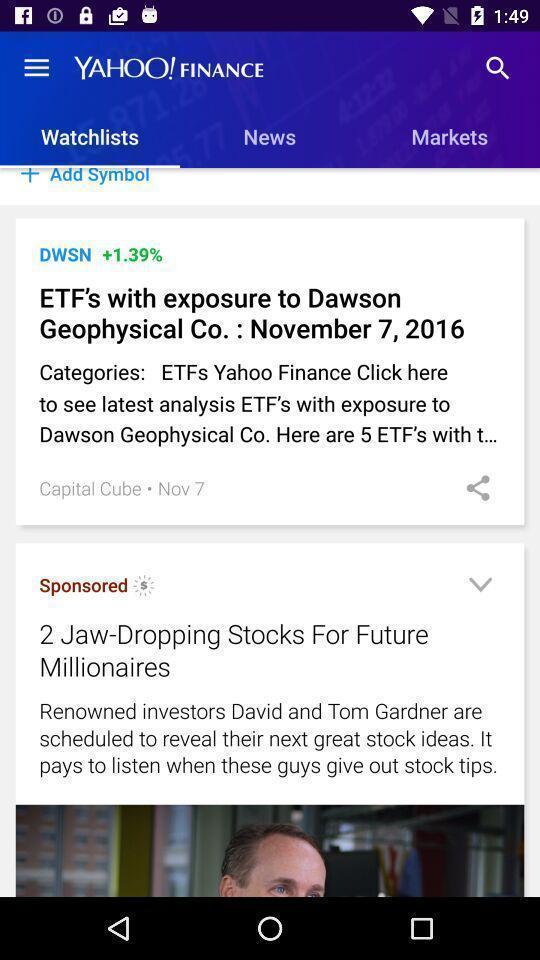Describe the content in this image. Watch lists page in a a finance app. 